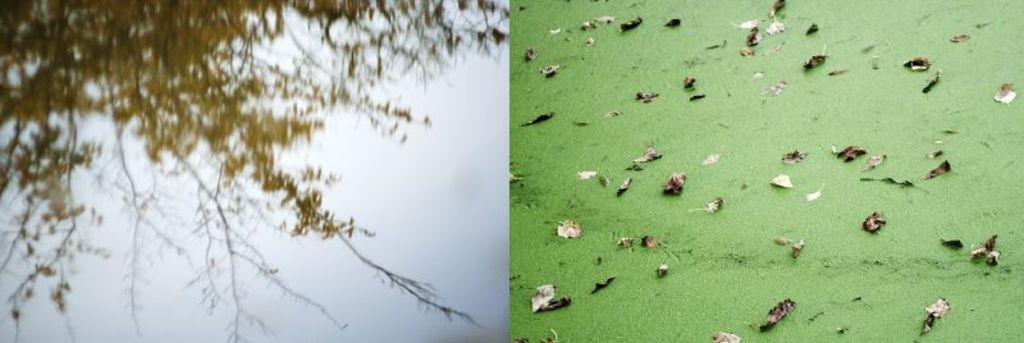What type of artwork is depicted in the image? The image is a collage. What can be seen on the left side of the collage? There are branches with leaves on the left side of the collage. What is featured on the right side of the collage? There are algae with leaves on the right side of the collage. What time of day is depicted in the image? The image does not depict a specific time of day, as it is a collage of branches and algae. Can you see a zebra in the image? No, there is no zebra present in the image. 